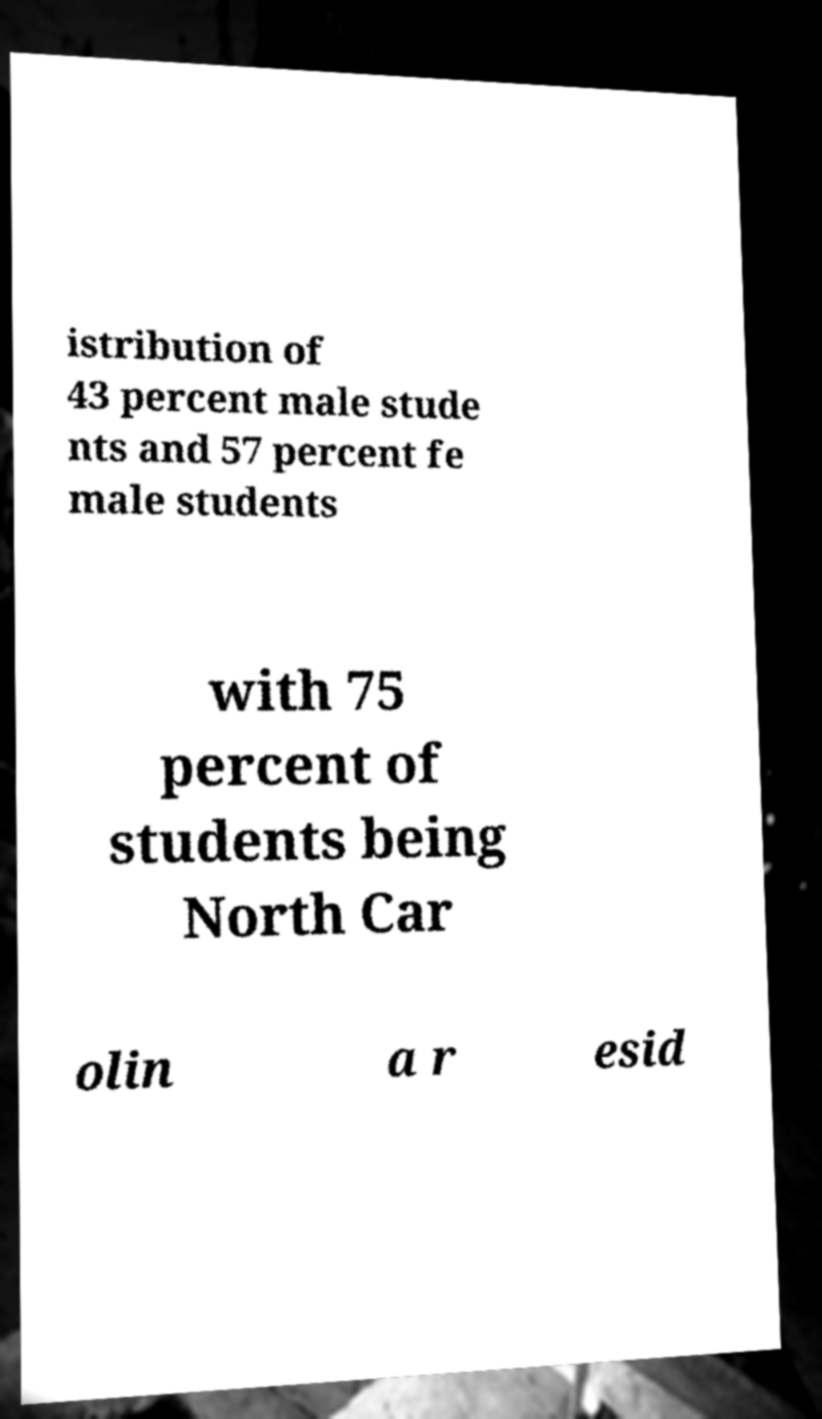I need the written content from this picture converted into text. Can you do that? istribution of 43 percent male stude nts and 57 percent fe male students with 75 percent of students being North Car olin a r esid 